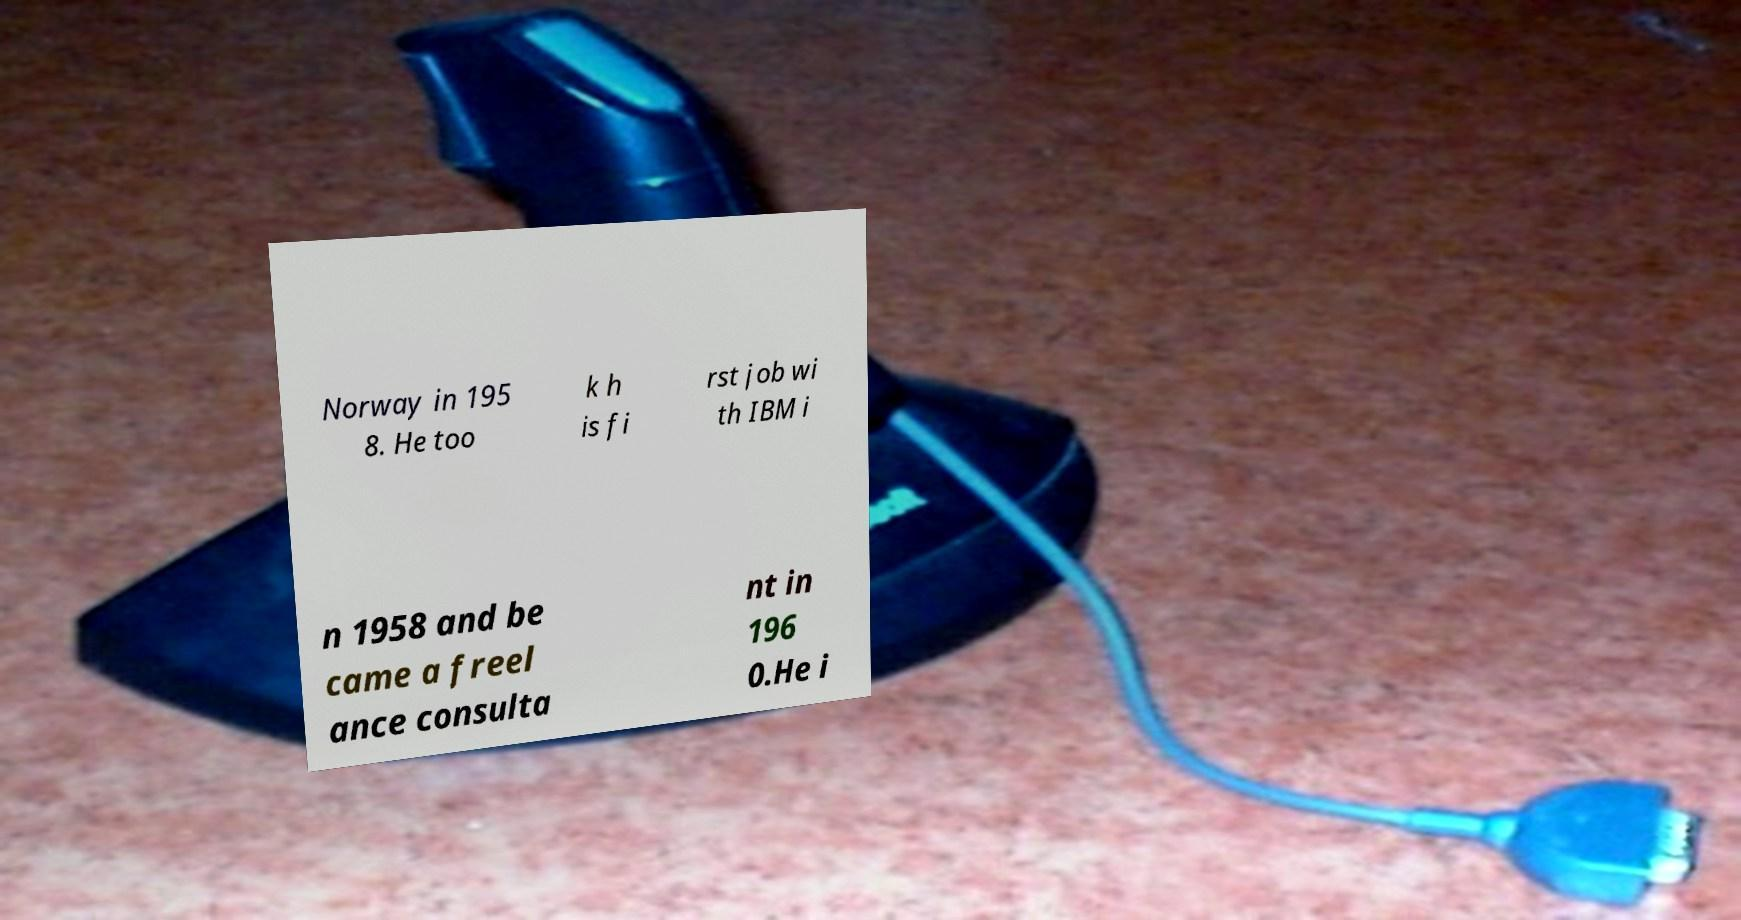Could you assist in decoding the text presented in this image and type it out clearly? Norway in 195 8. He too k h is fi rst job wi th IBM i n 1958 and be came a freel ance consulta nt in 196 0.He i 